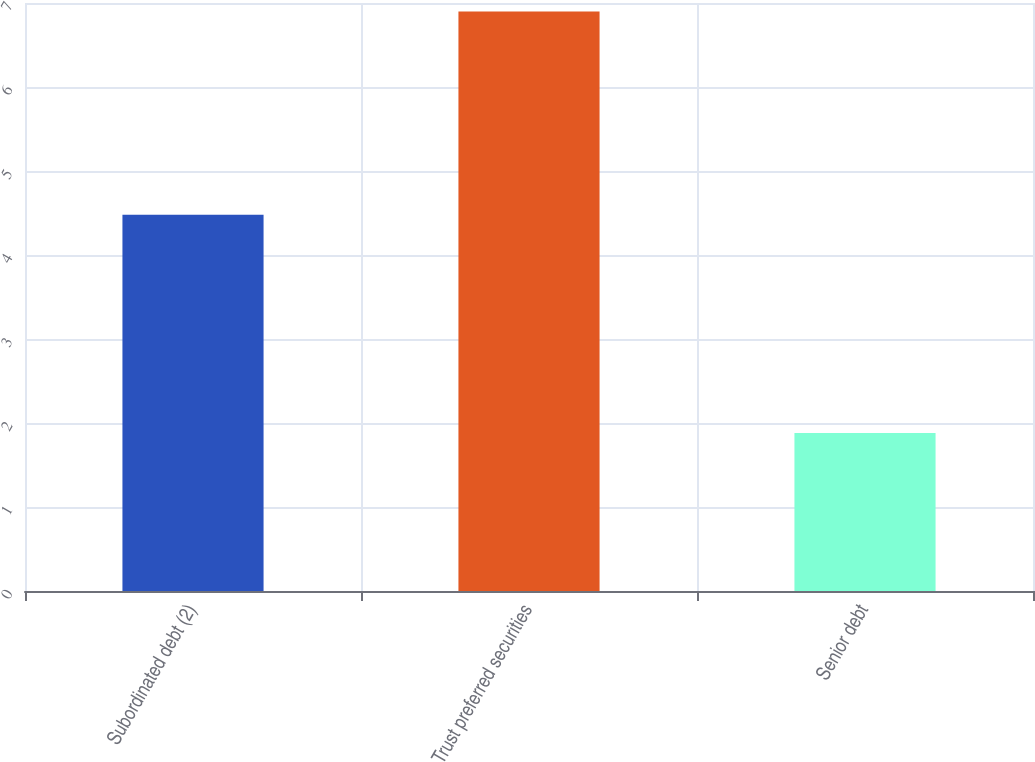<chart> <loc_0><loc_0><loc_500><loc_500><bar_chart><fcel>Subordinated debt (2)<fcel>Trust preferred securities<fcel>Senior debt<nl><fcel>4.48<fcel>6.9<fcel>1.88<nl></chart> 